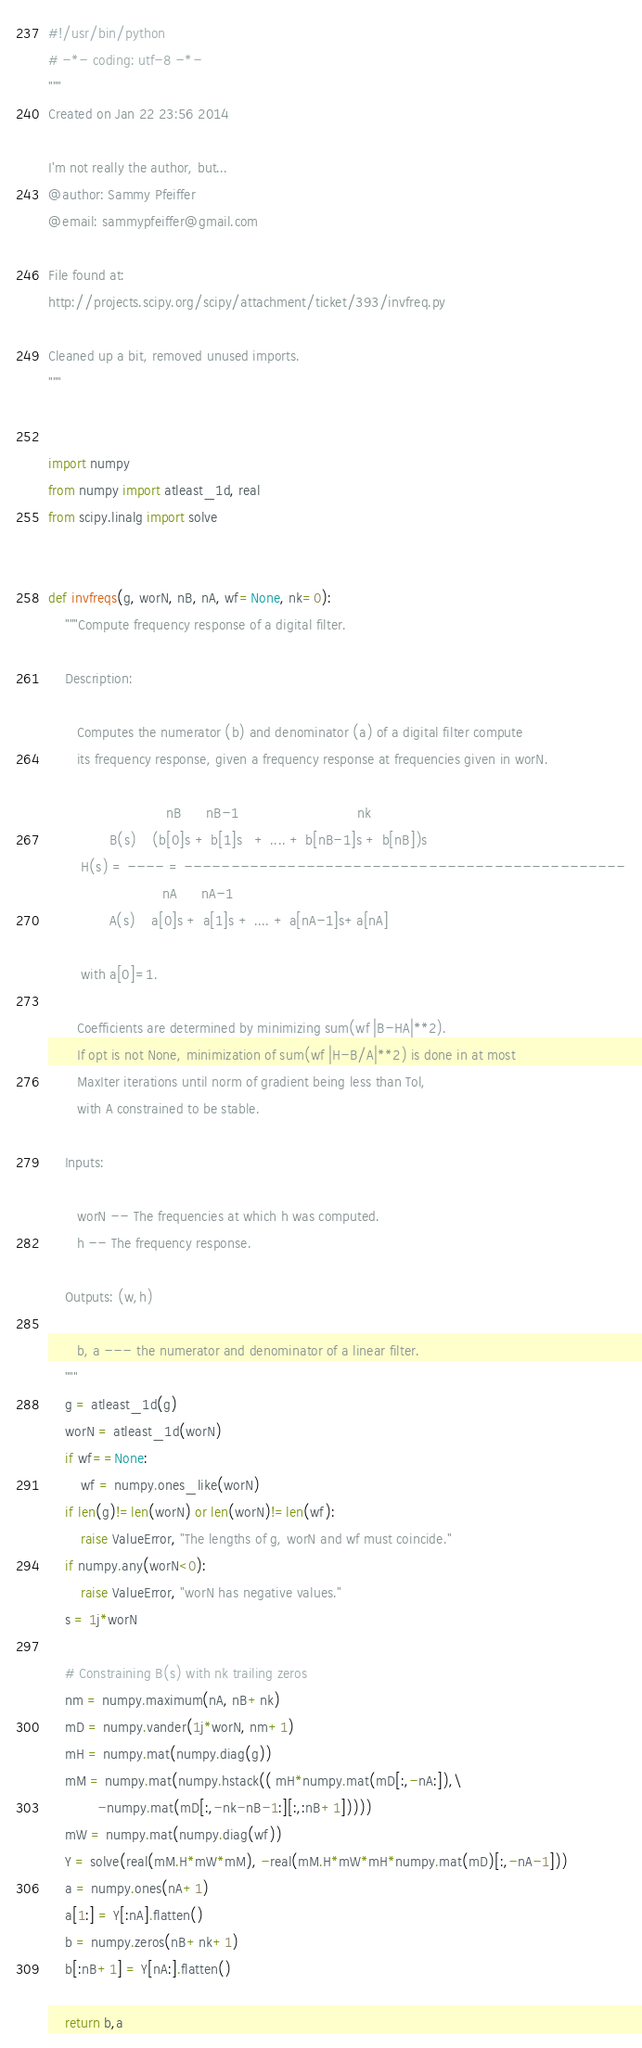Convert code to text. <code><loc_0><loc_0><loc_500><loc_500><_Python_>#!/usr/bin/python
# -*- coding: utf-8 -*-
"""
Created on Jan 22 23:56 2014

I'm not really the author, but...
@author: Sammy Pfeiffer
@email: sammypfeiffer@gmail.com

File found at:
http://projects.scipy.org/scipy/attachment/ticket/393/invfreq.py

Cleaned up a bit, removed unused imports.
"""


import numpy
from numpy import atleast_1d, real
from scipy.linalg import solve


def invfreqs(g, worN, nB, nA, wf=None, nk=0):
    """Compute frequency response of a digital filter.

    Description:

       Computes the numerator (b) and denominator (a) of a digital filter compute
       its frequency response, given a frequency response at frequencies given in worN.

                             nB      nB-1                             nk
               B(s)    (b[0]s + b[1]s   + .... + b[nB-1]s + b[nB])s
        H(s) = ---- = -----------------------------------------------
                            nA      nA-1
               A(s)    a[0]s + a[1]s + .... + a[nA-1]s+a[nA]

        with a[0]=1.

       Coefficients are determined by minimizing sum(wf |B-HA|**2).
       If opt is not None, minimization of sum(wf |H-B/A|**2) is done in at most
       MaxIter iterations until norm of gradient being less than Tol,
       with A constrained to be stable.

    Inputs:

       worN -- The frequencies at which h was computed.
       h -- The frequency response.

    Outputs: (w,h)

       b, a --- the numerator and denominator of a linear filter.
    """
    g = atleast_1d(g)
    worN = atleast_1d(worN)
    if wf==None:
        wf = numpy.ones_like(worN)
    if len(g)!=len(worN) or len(worN)!=len(wf):
        raise ValueError, "The lengths of g, worN and wf must coincide."
    if numpy.any(worN<0):
        raise ValueError, "worN has negative values."
    s = 1j*worN

    # Constraining B(s) with nk trailing zeros
    nm = numpy.maximum(nA, nB+nk)
    mD = numpy.vander(1j*worN, nm+1)
    mH = numpy.mat(numpy.diag(g))
    mM = numpy.mat(numpy.hstack(( mH*numpy.mat(mD[:,-nA:]),\
            -numpy.mat(mD[:,-nk-nB-1:][:,:nB+1]))))
    mW = numpy.mat(numpy.diag(wf))
    Y = solve(real(mM.H*mW*mM), -real(mM.H*mW*mH*numpy.mat(mD)[:,-nA-1]))
    a = numpy.ones(nA+1)
    a[1:] = Y[:nA].flatten()
    b = numpy.zeros(nB+nk+1)
    b[:nB+1] = Y[nA:].flatten()

    return b,a</code> 